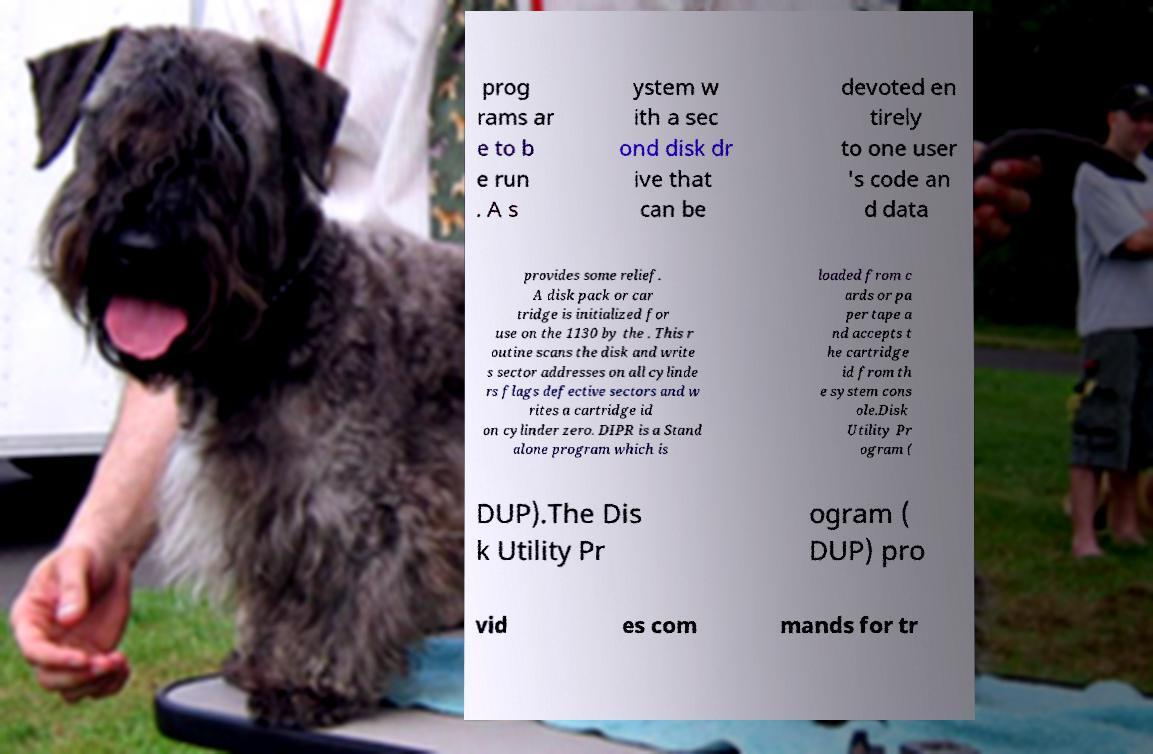There's text embedded in this image that I need extracted. Can you transcribe it verbatim? prog rams ar e to b e run . A s ystem w ith a sec ond disk dr ive that can be devoted en tirely to one user 's code an d data provides some relief. A disk pack or car tridge is initialized for use on the 1130 by the . This r outine scans the disk and write s sector addresses on all cylinde rs flags defective sectors and w rites a cartridge id on cylinder zero. DIPR is a Stand alone program which is loaded from c ards or pa per tape a nd accepts t he cartridge id from th e system cons ole.Disk Utility Pr ogram ( DUP).The Dis k Utility Pr ogram ( DUP) pro vid es com mands for tr 